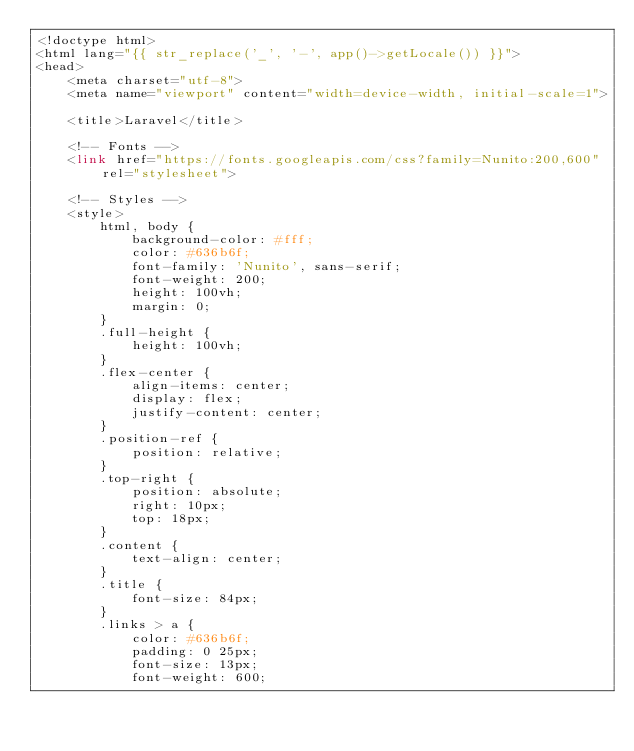Convert code to text. <code><loc_0><loc_0><loc_500><loc_500><_PHP_><!doctype html>
<html lang="{{ str_replace('_', '-', app()->getLocale()) }}">
<head>
    <meta charset="utf-8">
    <meta name="viewport" content="width=device-width, initial-scale=1">

    <title>Laravel</title>

    <!-- Fonts -->
    <link href="https://fonts.googleapis.com/css?family=Nunito:200,600" rel="stylesheet">

    <!-- Styles -->
    <style>
        html, body {
            background-color: #fff;
            color: #636b6f;
            font-family: 'Nunito', sans-serif;
            font-weight: 200;
            height: 100vh;
            margin: 0;
        }
        .full-height {
            height: 100vh;
        }
        .flex-center {
            align-items: center;
            display: flex;
            justify-content: center;
        }
        .position-ref {
            position: relative;
        }
        .top-right {
            position: absolute;
            right: 10px;
            top: 18px;
        }
        .content {
            text-align: center;
        }
        .title {
            font-size: 84px;
        }
        .links > a {
            color: #636b6f;
            padding: 0 25px;
            font-size: 13px;
            font-weight: 600;</code> 